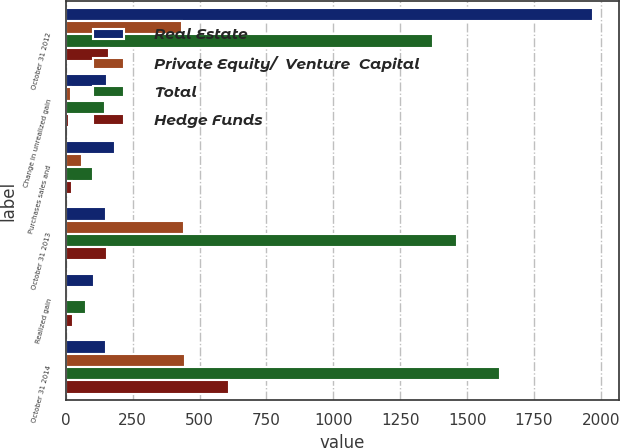Convert chart. <chart><loc_0><loc_0><loc_500><loc_500><stacked_bar_chart><ecel><fcel>October 31 2012<fcel>Change in unrealized gain<fcel>Purchases sales and<fcel>October 31 2013<fcel>Realized gain<fcel>October 31 2014<nl><fcel>Real Estate<fcel>1969<fcel>153<fcel>185<fcel>149<fcel>105<fcel>149<nl><fcel>Private Equity/  Venture  Capital<fcel>436<fcel>20<fcel>61<fcel>443<fcel>1<fcel>446<nl><fcel>Total<fcel>1373<fcel>145<fcel>102<fcel>1464<fcel>77<fcel>1622<nl><fcel>Hedge Funds<fcel>160<fcel>12<fcel>22<fcel>155<fcel>27<fcel>609<nl></chart> 